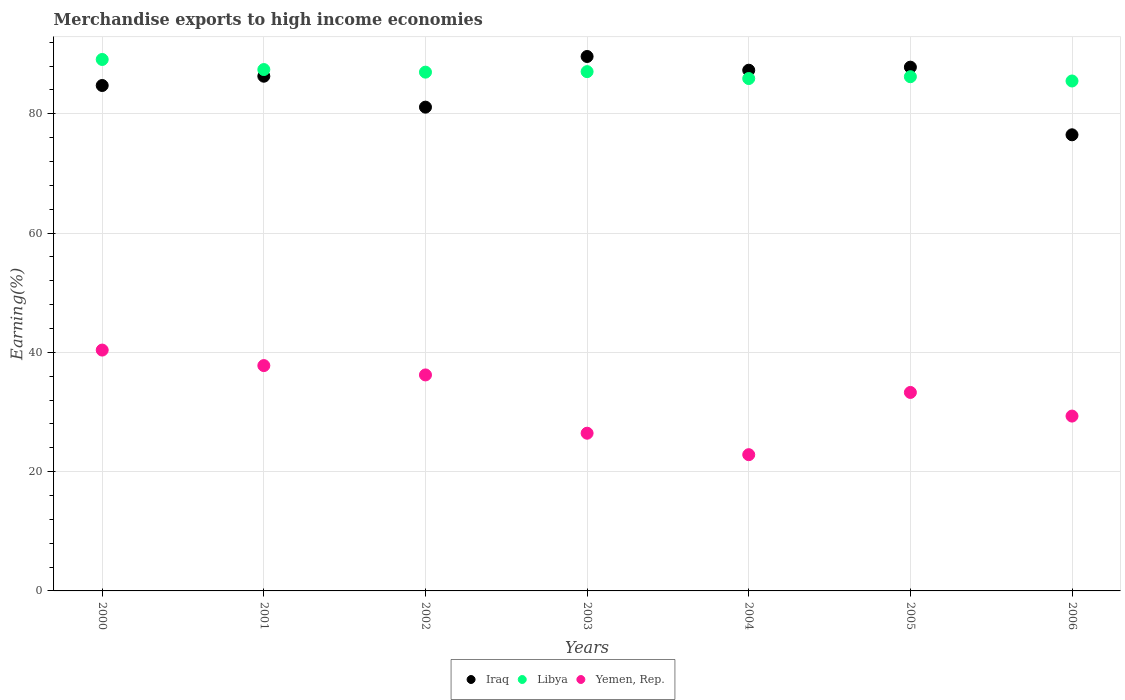Is the number of dotlines equal to the number of legend labels?
Offer a very short reply. Yes. What is the percentage of amount earned from merchandise exports in Libya in 2004?
Keep it short and to the point. 85.92. Across all years, what is the maximum percentage of amount earned from merchandise exports in Libya?
Ensure brevity in your answer.  89.11. Across all years, what is the minimum percentage of amount earned from merchandise exports in Yemen, Rep.?
Give a very brief answer. 22.85. In which year was the percentage of amount earned from merchandise exports in Yemen, Rep. minimum?
Offer a terse response. 2004. What is the total percentage of amount earned from merchandise exports in Libya in the graph?
Your answer should be very brief. 608.25. What is the difference between the percentage of amount earned from merchandise exports in Libya in 2000 and that in 2003?
Make the answer very short. 2.04. What is the difference between the percentage of amount earned from merchandise exports in Yemen, Rep. in 2004 and the percentage of amount earned from merchandise exports in Libya in 2005?
Your response must be concise. -63.38. What is the average percentage of amount earned from merchandise exports in Yemen, Rep. per year?
Make the answer very short. 32.33. In the year 2006, what is the difference between the percentage of amount earned from merchandise exports in Libya and percentage of amount earned from merchandise exports in Iraq?
Your answer should be very brief. 9.02. What is the ratio of the percentage of amount earned from merchandise exports in Yemen, Rep. in 2003 to that in 2004?
Keep it short and to the point. 1.16. What is the difference between the highest and the second highest percentage of amount earned from merchandise exports in Iraq?
Offer a very short reply. 1.79. What is the difference between the highest and the lowest percentage of amount earned from merchandise exports in Libya?
Give a very brief answer. 3.61. In how many years, is the percentage of amount earned from merchandise exports in Yemen, Rep. greater than the average percentage of amount earned from merchandise exports in Yemen, Rep. taken over all years?
Keep it short and to the point. 4. Does the percentage of amount earned from merchandise exports in Libya monotonically increase over the years?
Your answer should be very brief. No. Is the percentage of amount earned from merchandise exports in Yemen, Rep. strictly greater than the percentage of amount earned from merchandise exports in Iraq over the years?
Provide a short and direct response. No. Is the percentage of amount earned from merchandise exports in Iraq strictly less than the percentage of amount earned from merchandise exports in Libya over the years?
Provide a short and direct response. No. How many dotlines are there?
Ensure brevity in your answer.  3. Are the values on the major ticks of Y-axis written in scientific E-notation?
Provide a short and direct response. No. Does the graph contain any zero values?
Your answer should be compact. No. Does the graph contain grids?
Keep it short and to the point. Yes. Where does the legend appear in the graph?
Your response must be concise. Bottom center. How are the legend labels stacked?
Keep it short and to the point. Horizontal. What is the title of the graph?
Make the answer very short. Merchandise exports to high income economies. Does "Fragile and conflict affected situations" appear as one of the legend labels in the graph?
Offer a very short reply. No. What is the label or title of the Y-axis?
Provide a short and direct response. Earning(%). What is the Earning(%) in Iraq in 2000?
Make the answer very short. 84.75. What is the Earning(%) of Libya in 2000?
Provide a short and direct response. 89.11. What is the Earning(%) in Yemen, Rep. in 2000?
Your answer should be very brief. 40.39. What is the Earning(%) in Iraq in 2001?
Offer a very short reply. 86.31. What is the Earning(%) of Libya in 2001?
Provide a short and direct response. 87.42. What is the Earning(%) in Yemen, Rep. in 2001?
Ensure brevity in your answer.  37.78. What is the Earning(%) in Iraq in 2002?
Make the answer very short. 81.12. What is the Earning(%) in Libya in 2002?
Offer a very short reply. 86.99. What is the Earning(%) of Yemen, Rep. in 2002?
Ensure brevity in your answer.  36.22. What is the Earning(%) in Iraq in 2003?
Provide a succinct answer. 89.62. What is the Earning(%) of Libya in 2003?
Offer a very short reply. 87.07. What is the Earning(%) of Yemen, Rep. in 2003?
Your response must be concise. 26.45. What is the Earning(%) of Iraq in 2004?
Give a very brief answer. 87.31. What is the Earning(%) of Libya in 2004?
Your answer should be compact. 85.92. What is the Earning(%) in Yemen, Rep. in 2004?
Provide a short and direct response. 22.85. What is the Earning(%) of Iraq in 2005?
Keep it short and to the point. 87.83. What is the Earning(%) of Libya in 2005?
Offer a very short reply. 86.22. What is the Earning(%) of Yemen, Rep. in 2005?
Ensure brevity in your answer.  33.28. What is the Earning(%) in Iraq in 2006?
Keep it short and to the point. 76.48. What is the Earning(%) in Libya in 2006?
Your answer should be very brief. 85.51. What is the Earning(%) of Yemen, Rep. in 2006?
Provide a succinct answer. 29.32. Across all years, what is the maximum Earning(%) in Iraq?
Your response must be concise. 89.62. Across all years, what is the maximum Earning(%) of Libya?
Provide a succinct answer. 89.11. Across all years, what is the maximum Earning(%) of Yemen, Rep.?
Make the answer very short. 40.39. Across all years, what is the minimum Earning(%) of Iraq?
Ensure brevity in your answer.  76.48. Across all years, what is the minimum Earning(%) in Libya?
Offer a terse response. 85.51. Across all years, what is the minimum Earning(%) in Yemen, Rep.?
Offer a very short reply. 22.85. What is the total Earning(%) of Iraq in the graph?
Keep it short and to the point. 593.41. What is the total Earning(%) in Libya in the graph?
Give a very brief answer. 608.25. What is the total Earning(%) in Yemen, Rep. in the graph?
Make the answer very short. 226.28. What is the difference between the Earning(%) in Iraq in 2000 and that in 2001?
Offer a very short reply. -1.56. What is the difference between the Earning(%) in Libya in 2000 and that in 2001?
Your answer should be very brief. 1.69. What is the difference between the Earning(%) in Yemen, Rep. in 2000 and that in 2001?
Ensure brevity in your answer.  2.6. What is the difference between the Earning(%) of Iraq in 2000 and that in 2002?
Ensure brevity in your answer.  3.63. What is the difference between the Earning(%) of Libya in 2000 and that in 2002?
Keep it short and to the point. 2.12. What is the difference between the Earning(%) of Yemen, Rep. in 2000 and that in 2002?
Make the answer very short. 4.17. What is the difference between the Earning(%) in Iraq in 2000 and that in 2003?
Your answer should be very brief. -4.87. What is the difference between the Earning(%) of Libya in 2000 and that in 2003?
Provide a short and direct response. 2.04. What is the difference between the Earning(%) in Yemen, Rep. in 2000 and that in 2003?
Keep it short and to the point. 13.94. What is the difference between the Earning(%) of Iraq in 2000 and that in 2004?
Offer a terse response. -2.56. What is the difference between the Earning(%) of Libya in 2000 and that in 2004?
Your response must be concise. 3.2. What is the difference between the Earning(%) of Yemen, Rep. in 2000 and that in 2004?
Your answer should be compact. 17.54. What is the difference between the Earning(%) in Iraq in 2000 and that in 2005?
Your answer should be very brief. -3.08. What is the difference between the Earning(%) in Libya in 2000 and that in 2005?
Offer a terse response. 2.89. What is the difference between the Earning(%) in Yemen, Rep. in 2000 and that in 2005?
Make the answer very short. 7.1. What is the difference between the Earning(%) in Iraq in 2000 and that in 2006?
Make the answer very short. 8.27. What is the difference between the Earning(%) in Libya in 2000 and that in 2006?
Provide a succinct answer. 3.61. What is the difference between the Earning(%) of Yemen, Rep. in 2000 and that in 2006?
Your answer should be compact. 11.07. What is the difference between the Earning(%) in Iraq in 2001 and that in 2002?
Your response must be concise. 5.19. What is the difference between the Earning(%) in Libya in 2001 and that in 2002?
Offer a terse response. 0.44. What is the difference between the Earning(%) of Yemen, Rep. in 2001 and that in 2002?
Offer a very short reply. 1.57. What is the difference between the Earning(%) in Iraq in 2001 and that in 2003?
Offer a very short reply. -3.31. What is the difference between the Earning(%) of Libya in 2001 and that in 2003?
Your response must be concise. 0.35. What is the difference between the Earning(%) of Yemen, Rep. in 2001 and that in 2003?
Provide a short and direct response. 11.34. What is the difference between the Earning(%) in Iraq in 2001 and that in 2004?
Provide a short and direct response. -1.01. What is the difference between the Earning(%) in Libya in 2001 and that in 2004?
Make the answer very short. 1.51. What is the difference between the Earning(%) in Yemen, Rep. in 2001 and that in 2004?
Your answer should be very brief. 14.94. What is the difference between the Earning(%) of Iraq in 2001 and that in 2005?
Your response must be concise. -1.52. What is the difference between the Earning(%) of Libya in 2001 and that in 2005?
Offer a very short reply. 1.2. What is the difference between the Earning(%) in Yemen, Rep. in 2001 and that in 2005?
Your answer should be compact. 4.5. What is the difference between the Earning(%) of Iraq in 2001 and that in 2006?
Keep it short and to the point. 9.82. What is the difference between the Earning(%) in Libya in 2001 and that in 2006?
Your response must be concise. 1.92. What is the difference between the Earning(%) in Yemen, Rep. in 2001 and that in 2006?
Give a very brief answer. 8.47. What is the difference between the Earning(%) in Iraq in 2002 and that in 2003?
Offer a terse response. -8.5. What is the difference between the Earning(%) of Libya in 2002 and that in 2003?
Keep it short and to the point. -0.09. What is the difference between the Earning(%) in Yemen, Rep. in 2002 and that in 2003?
Offer a terse response. 9.77. What is the difference between the Earning(%) of Iraq in 2002 and that in 2004?
Provide a succinct answer. -6.19. What is the difference between the Earning(%) in Libya in 2002 and that in 2004?
Offer a terse response. 1.07. What is the difference between the Earning(%) in Yemen, Rep. in 2002 and that in 2004?
Provide a short and direct response. 13.37. What is the difference between the Earning(%) of Iraq in 2002 and that in 2005?
Give a very brief answer. -6.71. What is the difference between the Earning(%) of Libya in 2002 and that in 2005?
Your response must be concise. 0.77. What is the difference between the Earning(%) in Yemen, Rep. in 2002 and that in 2005?
Your response must be concise. 2.94. What is the difference between the Earning(%) of Iraq in 2002 and that in 2006?
Your answer should be very brief. 4.64. What is the difference between the Earning(%) of Libya in 2002 and that in 2006?
Provide a short and direct response. 1.48. What is the difference between the Earning(%) in Yemen, Rep. in 2002 and that in 2006?
Your answer should be compact. 6.9. What is the difference between the Earning(%) of Iraq in 2003 and that in 2004?
Offer a terse response. 2.3. What is the difference between the Earning(%) of Libya in 2003 and that in 2004?
Provide a succinct answer. 1.16. What is the difference between the Earning(%) of Yemen, Rep. in 2003 and that in 2004?
Offer a very short reply. 3.6. What is the difference between the Earning(%) of Iraq in 2003 and that in 2005?
Provide a succinct answer. 1.79. What is the difference between the Earning(%) of Libya in 2003 and that in 2005?
Offer a very short reply. 0.85. What is the difference between the Earning(%) in Yemen, Rep. in 2003 and that in 2005?
Your answer should be very brief. -6.84. What is the difference between the Earning(%) in Iraq in 2003 and that in 2006?
Give a very brief answer. 13.13. What is the difference between the Earning(%) in Libya in 2003 and that in 2006?
Provide a short and direct response. 1.57. What is the difference between the Earning(%) in Yemen, Rep. in 2003 and that in 2006?
Keep it short and to the point. -2.87. What is the difference between the Earning(%) in Iraq in 2004 and that in 2005?
Your response must be concise. -0.51. What is the difference between the Earning(%) in Libya in 2004 and that in 2005?
Ensure brevity in your answer.  -0.31. What is the difference between the Earning(%) in Yemen, Rep. in 2004 and that in 2005?
Your response must be concise. -10.44. What is the difference between the Earning(%) of Iraq in 2004 and that in 2006?
Provide a succinct answer. 10.83. What is the difference between the Earning(%) in Libya in 2004 and that in 2006?
Provide a short and direct response. 0.41. What is the difference between the Earning(%) in Yemen, Rep. in 2004 and that in 2006?
Make the answer very short. -6.47. What is the difference between the Earning(%) in Iraq in 2005 and that in 2006?
Offer a very short reply. 11.34. What is the difference between the Earning(%) in Libya in 2005 and that in 2006?
Provide a short and direct response. 0.72. What is the difference between the Earning(%) of Yemen, Rep. in 2005 and that in 2006?
Make the answer very short. 3.96. What is the difference between the Earning(%) of Iraq in 2000 and the Earning(%) of Libya in 2001?
Ensure brevity in your answer.  -2.67. What is the difference between the Earning(%) of Iraq in 2000 and the Earning(%) of Yemen, Rep. in 2001?
Offer a terse response. 46.97. What is the difference between the Earning(%) of Libya in 2000 and the Earning(%) of Yemen, Rep. in 2001?
Offer a very short reply. 51.33. What is the difference between the Earning(%) of Iraq in 2000 and the Earning(%) of Libya in 2002?
Provide a succinct answer. -2.24. What is the difference between the Earning(%) in Iraq in 2000 and the Earning(%) in Yemen, Rep. in 2002?
Give a very brief answer. 48.53. What is the difference between the Earning(%) in Libya in 2000 and the Earning(%) in Yemen, Rep. in 2002?
Your answer should be compact. 52.9. What is the difference between the Earning(%) of Iraq in 2000 and the Earning(%) of Libya in 2003?
Your answer should be very brief. -2.33. What is the difference between the Earning(%) in Iraq in 2000 and the Earning(%) in Yemen, Rep. in 2003?
Your response must be concise. 58.3. What is the difference between the Earning(%) of Libya in 2000 and the Earning(%) of Yemen, Rep. in 2003?
Offer a terse response. 62.67. What is the difference between the Earning(%) of Iraq in 2000 and the Earning(%) of Libya in 2004?
Make the answer very short. -1.17. What is the difference between the Earning(%) of Iraq in 2000 and the Earning(%) of Yemen, Rep. in 2004?
Make the answer very short. 61.9. What is the difference between the Earning(%) in Libya in 2000 and the Earning(%) in Yemen, Rep. in 2004?
Your answer should be very brief. 66.27. What is the difference between the Earning(%) of Iraq in 2000 and the Earning(%) of Libya in 2005?
Offer a terse response. -1.47. What is the difference between the Earning(%) of Iraq in 2000 and the Earning(%) of Yemen, Rep. in 2005?
Your response must be concise. 51.47. What is the difference between the Earning(%) of Libya in 2000 and the Earning(%) of Yemen, Rep. in 2005?
Keep it short and to the point. 55.83. What is the difference between the Earning(%) in Iraq in 2000 and the Earning(%) in Libya in 2006?
Your answer should be very brief. -0.76. What is the difference between the Earning(%) of Iraq in 2000 and the Earning(%) of Yemen, Rep. in 2006?
Ensure brevity in your answer.  55.43. What is the difference between the Earning(%) of Libya in 2000 and the Earning(%) of Yemen, Rep. in 2006?
Your answer should be compact. 59.8. What is the difference between the Earning(%) in Iraq in 2001 and the Earning(%) in Libya in 2002?
Your response must be concise. -0.68. What is the difference between the Earning(%) of Iraq in 2001 and the Earning(%) of Yemen, Rep. in 2002?
Your response must be concise. 50.09. What is the difference between the Earning(%) of Libya in 2001 and the Earning(%) of Yemen, Rep. in 2002?
Keep it short and to the point. 51.21. What is the difference between the Earning(%) in Iraq in 2001 and the Earning(%) in Libya in 2003?
Provide a succinct answer. -0.77. What is the difference between the Earning(%) in Iraq in 2001 and the Earning(%) in Yemen, Rep. in 2003?
Offer a very short reply. 59.86. What is the difference between the Earning(%) in Libya in 2001 and the Earning(%) in Yemen, Rep. in 2003?
Keep it short and to the point. 60.98. What is the difference between the Earning(%) in Iraq in 2001 and the Earning(%) in Libya in 2004?
Ensure brevity in your answer.  0.39. What is the difference between the Earning(%) in Iraq in 2001 and the Earning(%) in Yemen, Rep. in 2004?
Ensure brevity in your answer.  63.46. What is the difference between the Earning(%) in Libya in 2001 and the Earning(%) in Yemen, Rep. in 2004?
Give a very brief answer. 64.58. What is the difference between the Earning(%) in Iraq in 2001 and the Earning(%) in Libya in 2005?
Your answer should be compact. 0.08. What is the difference between the Earning(%) of Iraq in 2001 and the Earning(%) of Yemen, Rep. in 2005?
Keep it short and to the point. 53.03. What is the difference between the Earning(%) of Libya in 2001 and the Earning(%) of Yemen, Rep. in 2005?
Make the answer very short. 54.14. What is the difference between the Earning(%) of Iraq in 2001 and the Earning(%) of Libya in 2006?
Offer a terse response. 0.8. What is the difference between the Earning(%) in Iraq in 2001 and the Earning(%) in Yemen, Rep. in 2006?
Give a very brief answer. 56.99. What is the difference between the Earning(%) of Libya in 2001 and the Earning(%) of Yemen, Rep. in 2006?
Your answer should be compact. 58.11. What is the difference between the Earning(%) in Iraq in 2002 and the Earning(%) in Libya in 2003?
Make the answer very short. -5.96. What is the difference between the Earning(%) of Iraq in 2002 and the Earning(%) of Yemen, Rep. in 2003?
Ensure brevity in your answer.  54.67. What is the difference between the Earning(%) of Libya in 2002 and the Earning(%) of Yemen, Rep. in 2003?
Offer a very short reply. 60.54. What is the difference between the Earning(%) of Iraq in 2002 and the Earning(%) of Libya in 2004?
Your answer should be very brief. -4.8. What is the difference between the Earning(%) in Iraq in 2002 and the Earning(%) in Yemen, Rep. in 2004?
Offer a very short reply. 58.27. What is the difference between the Earning(%) in Libya in 2002 and the Earning(%) in Yemen, Rep. in 2004?
Give a very brief answer. 64.14. What is the difference between the Earning(%) in Iraq in 2002 and the Earning(%) in Libya in 2005?
Make the answer very short. -5.1. What is the difference between the Earning(%) in Iraq in 2002 and the Earning(%) in Yemen, Rep. in 2005?
Offer a terse response. 47.84. What is the difference between the Earning(%) in Libya in 2002 and the Earning(%) in Yemen, Rep. in 2005?
Ensure brevity in your answer.  53.71. What is the difference between the Earning(%) in Iraq in 2002 and the Earning(%) in Libya in 2006?
Your response must be concise. -4.39. What is the difference between the Earning(%) of Iraq in 2002 and the Earning(%) of Yemen, Rep. in 2006?
Your response must be concise. 51.8. What is the difference between the Earning(%) of Libya in 2002 and the Earning(%) of Yemen, Rep. in 2006?
Your answer should be compact. 57.67. What is the difference between the Earning(%) of Iraq in 2003 and the Earning(%) of Libya in 2004?
Provide a short and direct response. 3.7. What is the difference between the Earning(%) of Iraq in 2003 and the Earning(%) of Yemen, Rep. in 2004?
Give a very brief answer. 66.77. What is the difference between the Earning(%) of Libya in 2003 and the Earning(%) of Yemen, Rep. in 2004?
Keep it short and to the point. 64.23. What is the difference between the Earning(%) in Iraq in 2003 and the Earning(%) in Libya in 2005?
Your answer should be very brief. 3.39. What is the difference between the Earning(%) in Iraq in 2003 and the Earning(%) in Yemen, Rep. in 2005?
Your answer should be compact. 56.33. What is the difference between the Earning(%) in Libya in 2003 and the Earning(%) in Yemen, Rep. in 2005?
Your answer should be compact. 53.79. What is the difference between the Earning(%) in Iraq in 2003 and the Earning(%) in Libya in 2006?
Ensure brevity in your answer.  4.11. What is the difference between the Earning(%) in Iraq in 2003 and the Earning(%) in Yemen, Rep. in 2006?
Offer a very short reply. 60.3. What is the difference between the Earning(%) of Libya in 2003 and the Earning(%) of Yemen, Rep. in 2006?
Give a very brief answer. 57.76. What is the difference between the Earning(%) in Iraq in 2004 and the Earning(%) in Libya in 2005?
Your answer should be very brief. 1.09. What is the difference between the Earning(%) in Iraq in 2004 and the Earning(%) in Yemen, Rep. in 2005?
Your answer should be very brief. 54.03. What is the difference between the Earning(%) of Libya in 2004 and the Earning(%) of Yemen, Rep. in 2005?
Your response must be concise. 52.63. What is the difference between the Earning(%) in Iraq in 2004 and the Earning(%) in Libya in 2006?
Your response must be concise. 1.81. What is the difference between the Earning(%) of Iraq in 2004 and the Earning(%) of Yemen, Rep. in 2006?
Offer a very short reply. 58. What is the difference between the Earning(%) in Libya in 2004 and the Earning(%) in Yemen, Rep. in 2006?
Provide a succinct answer. 56.6. What is the difference between the Earning(%) in Iraq in 2005 and the Earning(%) in Libya in 2006?
Provide a succinct answer. 2.32. What is the difference between the Earning(%) of Iraq in 2005 and the Earning(%) of Yemen, Rep. in 2006?
Keep it short and to the point. 58.51. What is the difference between the Earning(%) in Libya in 2005 and the Earning(%) in Yemen, Rep. in 2006?
Ensure brevity in your answer.  56.9. What is the average Earning(%) in Iraq per year?
Give a very brief answer. 84.77. What is the average Earning(%) in Libya per year?
Offer a terse response. 86.89. What is the average Earning(%) in Yemen, Rep. per year?
Your response must be concise. 32.33. In the year 2000, what is the difference between the Earning(%) of Iraq and Earning(%) of Libya?
Keep it short and to the point. -4.36. In the year 2000, what is the difference between the Earning(%) in Iraq and Earning(%) in Yemen, Rep.?
Give a very brief answer. 44.36. In the year 2000, what is the difference between the Earning(%) in Libya and Earning(%) in Yemen, Rep.?
Offer a very short reply. 48.73. In the year 2001, what is the difference between the Earning(%) in Iraq and Earning(%) in Libya?
Provide a succinct answer. -1.12. In the year 2001, what is the difference between the Earning(%) of Iraq and Earning(%) of Yemen, Rep.?
Your answer should be very brief. 48.52. In the year 2001, what is the difference between the Earning(%) of Libya and Earning(%) of Yemen, Rep.?
Provide a short and direct response. 49.64. In the year 2002, what is the difference between the Earning(%) in Iraq and Earning(%) in Libya?
Offer a terse response. -5.87. In the year 2002, what is the difference between the Earning(%) of Iraq and Earning(%) of Yemen, Rep.?
Offer a terse response. 44.9. In the year 2002, what is the difference between the Earning(%) in Libya and Earning(%) in Yemen, Rep.?
Your answer should be very brief. 50.77. In the year 2003, what is the difference between the Earning(%) in Iraq and Earning(%) in Libya?
Your answer should be compact. 2.54. In the year 2003, what is the difference between the Earning(%) of Iraq and Earning(%) of Yemen, Rep.?
Provide a succinct answer. 63.17. In the year 2003, what is the difference between the Earning(%) of Libya and Earning(%) of Yemen, Rep.?
Your answer should be very brief. 60.63. In the year 2004, what is the difference between the Earning(%) in Iraq and Earning(%) in Libya?
Offer a very short reply. 1.4. In the year 2004, what is the difference between the Earning(%) of Iraq and Earning(%) of Yemen, Rep.?
Your answer should be compact. 64.47. In the year 2004, what is the difference between the Earning(%) in Libya and Earning(%) in Yemen, Rep.?
Your answer should be compact. 63.07. In the year 2005, what is the difference between the Earning(%) in Iraq and Earning(%) in Libya?
Your answer should be compact. 1.6. In the year 2005, what is the difference between the Earning(%) of Iraq and Earning(%) of Yemen, Rep.?
Your answer should be compact. 54.54. In the year 2005, what is the difference between the Earning(%) of Libya and Earning(%) of Yemen, Rep.?
Your answer should be very brief. 52.94. In the year 2006, what is the difference between the Earning(%) of Iraq and Earning(%) of Libya?
Ensure brevity in your answer.  -9.02. In the year 2006, what is the difference between the Earning(%) in Iraq and Earning(%) in Yemen, Rep.?
Provide a succinct answer. 47.16. In the year 2006, what is the difference between the Earning(%) of Libya and Earning(%) of Yemen, Rep.?
Your answer should be very brief. 56.19. What is the ratio of the Earning(%) of Libya in 2000 to that in 2001?
Provide a short and direct response. 1.02. What is the ratio of the Earning(%) in Yemen, Rep. in 2000 to that in 2001?
Ensure brevity in your answer.  1.07. What is the ratio of the Earning(%) of Iraq in 2000 to that in 2002?
Provide a succinct answer. 1.04. What is the ratio of the Earning(%) of Libya in 2000 to that in 2002?
Your response must be concise. 1.02. What is the ratio of the Earning(%) in Yemen, Rep. in 2000 to that in 2002?
Ensure brevity in your answer.  1.12. What is the ratio of the Earning(%) of Iraq in 2000 to that in 2003?
Your response must be concise. 0.95. What is the ratio of the Earning(%) in Libya in 2000 to that in 2003?
Offer a very short reply. 1.02. What is the ratio of the Earning(%) in Yemen, Rep. in 2000 to that in 2003?
Make the answer very short. 1.53. What is the ratio of the Earning(%) of Iraq in 2000 to that in 2004?
Your answer should be compact. 0.97. What is the ratio of the Earning(%) of Libya in 2000 to that in 2004?
Offer a terse response. 1.04. What is the ratio of the Earning(%) of Yemen, Rep. in 2000 to that in 2004?
Provide a short and direct response. 1.77. What is the ratio of the Earning(%) of Libya in 2000 to that in 2005?
Offer a very short reply. 1.03. What is the ratio of the Earning(%) in Yemen, Rep. in 2000 to that in 2005?
Make the answer very short. 1.21. What is the ratio of the Earning(%) in Iraq in 2000 to that in 2006?
Your answer should be very brief. 1.11. What is the ratio of the Earning(%) of Libya in 2000 to that in 2006?
Offer a terse response. 1.04. What is the ratio of the Earning(%) of Yemen, Rep. in 2000 to that in 2006?
Offer a very short reply. 1.38. What is the ratio of the Earning(%) in Iraq in 2001 to that in 2002?
Offer a terse response. 1.06. What is the ratio of the Earning(%) in Libya in 2001 to that in 2002?
Provide a succinct answer. 1. What is the ratio of the Earning(%) of Yemen, Rep. in 2001 to that in 2002?
Provide a succinct answer. 1.04. What is the ratio of the Earning(%) of Iraq in 2001 to that in 2003?
Offer a very short reply. 0.96. What is the ratio of the Earning(%) of Yemen, Rep. in 2001 to that in 2003?
Make the answer very short. 1.43. What is the ratio of the Earning(%) in Iraq in 2001 to that in 2004?
Your answer should be very brief. 0.99. What is the ratio of the Earning(%) of Libya in 2001 to that in 2004?
Provide a short and direct response. 1.02. What is the ratio of the Earning(%) in Yemen, Rep. in 2001 to that in 2004?
Your answer should be very brief. 1.65. What is the ratio of the Earning(%) of Iraq in 2001 to that in 2005?
Your response must be concise. 0.98. What is the ratio of the Earning(%) in Libya in 2001 to that in 2005?
Your answer should be very brief. 1.01. What is the ratio of the Earning(%) of Yemen, Rep. in 2001 to that in 2005?
Ensure brevity in your answer.  1.14. What is the ratio of the Earning(%) in Iraq in 2001 to that in 2006?
Your answer should be compact. 1.13. What is the ratio of the Earning(%) of Libya in 2001 to that in 2006?
Offer a terse response. 1.02. What is the ratio of the Earning(%) of Yemen, Rep. in 2001 to that in 2006?
Keep it short and to the point. 1.29. What is the ratio of the Earning(%) in Iraq in 2002 to that in 2003?
Give a very brief answer. 0.91. What is the ratio of the Earning(%) in Libya in 2002 to that in 2003?
Make the answer very short. 1. What is the ratio of the Earning(%) of Yemen, Rep. in 2002 to that in 2003?
Ensure brevity in your answer.  1.37. What is the ratio of the Earning(%) of Iraq in 2002 to that in 2004?
Provide a succinct answer. 0.93. What is the ratio of the Earning(%) of Libya in 2002 to that in 2004?
Make the answer very short. 1.01. What is the ratio of the Earning(%) of Yemen, Rep. in 2002 to that in 2004?
Provide a succinct answer. 1.59. What is the ratio of the Earning(%) in Iraq in 2002 to that in 2005?
Give a very brief answer. 0.92. What is the ratio of the Earning(%) in Libya in 2002 to that in 2005?
Give a very brief answer. 1.01. What is the ratio of the Earning(%) in Yemen, Rep. in 2002 to that in 2005?
Make the answer very short. 1.09. What is the ratio of the Earning(%) of Iraq in 2002 to that in 2006?
Make the answer very short. 1.06. What is the ratio of the Earning(%) in Libya in 2002 to that in 2006?
Your answer should be compact. 1.02. What is the ratio of the Earning(%) in Yemen, Rep. in 2002 to that in 2006?
Keep it short and to the point. 1.24. What is the ratio of the Earning(%) of Iraq in 2003 to that in 2004?
Offer a terse response. 1.03. What is the ratio of the Earning(%) in Libya in 2003 to that in 2004?
Offer a very short reply. 1.01. What is the ratio of the Earning(%) of Yemen, Rep. in 2003 to that in 2004?
Make the answer very short. 1.16. What is the ratio of the Earning(%) in Iraq in 2003 to that in 2005?
Provide a succinct answer. 1.02. What is the ratio of the Earning(%) of Libya in 2003 to that in 2005?
Provide a short and direct response. 1.01. What is the ratio of the Earning(%) of Yemen, Rep. in 2003 to that in 2005?
Offer a very short reply. 0.79. What is the ratio of the Earning(%) in Iraq in 2003 to that in 2006?
Ensure brevity in your answer.  1.17. What is the ratio of the Earning(%) of Libya in 2003 to that in 2006?
Give a very brief answer. 1.02. What is the ratio of the Earning(%) of Yemen, Rep. in 2003 to that in 2006?
Give a very brief answer. 0.9. What is the ratio of the Earning(%) of Yemen, Rep. in 2004 to that in 2005?
Offer a terse response. 0.69. What is the ratio of the Earning(%) of Iraq in 2004 to that in 2006?
Your response must be concise. 1.14. What is the ratio of the Earning(%) in Yemen, Rep. in 2004 to that in 2006?
Make the answer very short. 0.78. What is the ratio of the Earning(%) of Iraq in 2005 to that in 2006?
Provide a short and direct response. 1.15. What is the ratio of the Earning(%) of Libya in 2005 to that in 2006?
Your response must be concise. 1.01. What is the ratio of the Earning(%) of Yemen, Rep. in 2005 to that in 2006?
Offer a terse response. 1.14. What is the difference between the highest and the second highest Earning(%) of Iraq?
Ensure brevity in your answer.  1.79. What is the difference between the highest and the second highest Earning(%) in Libya?
Your answer should be very brief. 1.69. What is the difference between the highest and the second highest Earning(%) in Yemen, Rep.?
Ensure brevity in your answer.  2.6. What is the difference between the highest and the lowest Earning(%) of Iraq?
Your response must be concise. 13.13. What is the difference between the highest and the lowest Earning(%) in Libya?
Make the answer very short. 3.61. What is the difference between the highest and the lowest Earning(%) in Yemen, Rep.?
Your response must be concise. 17.54. 